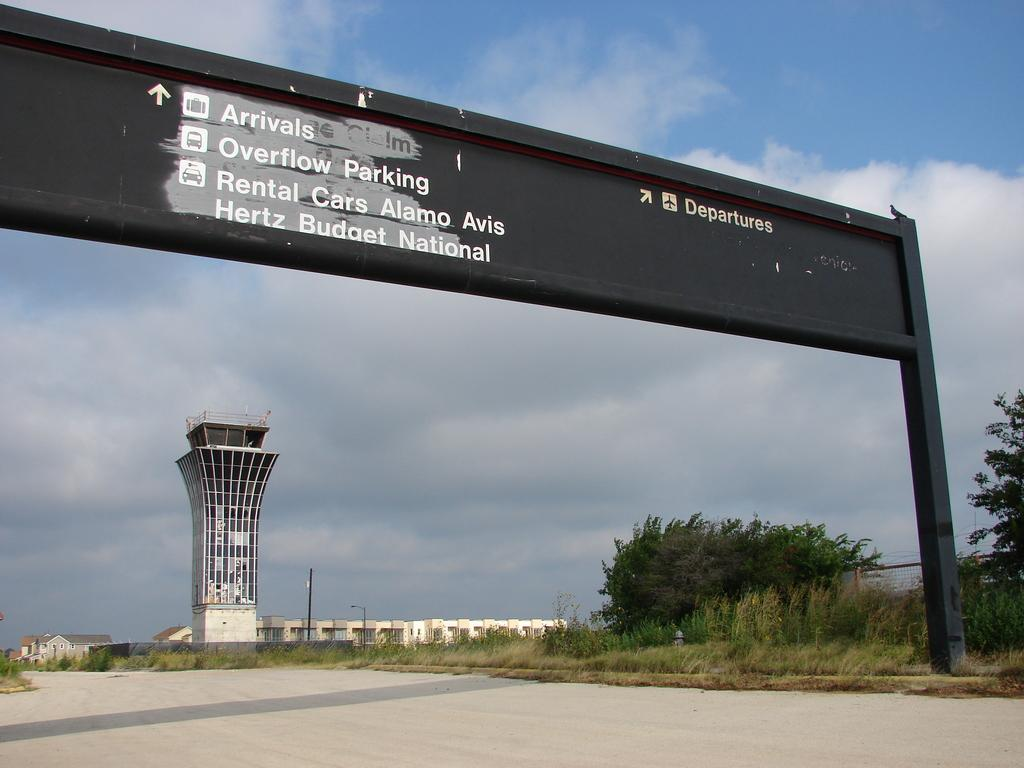<image>
Give a short and clear explanation of the subsequent image. A sign pointing the way to Arrivals and Overflow Parking hangs above the road 